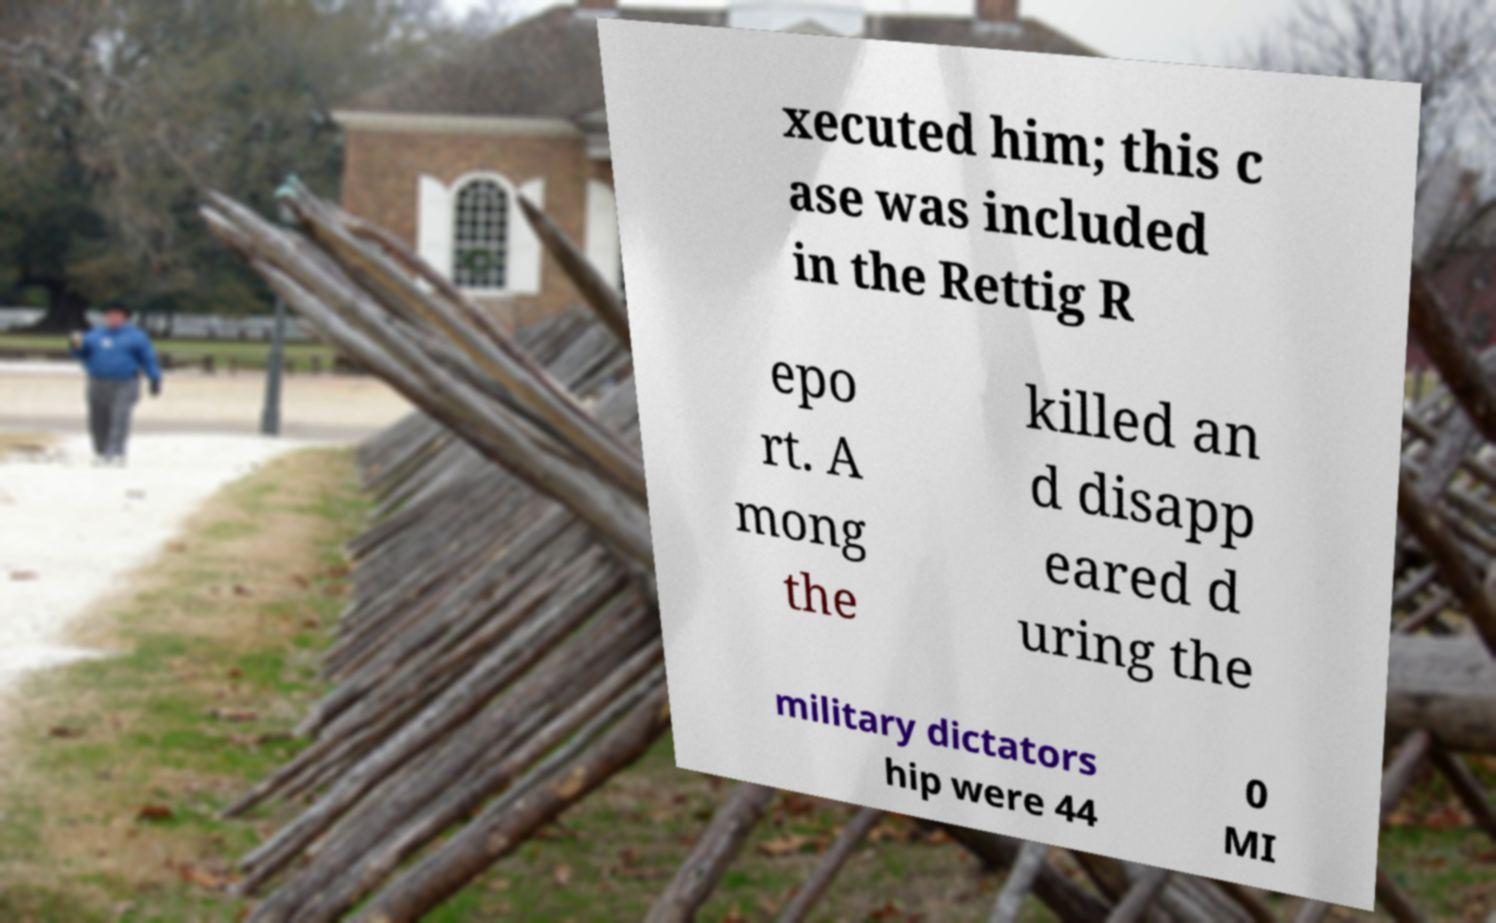Could you assist in decoding the text presented in this image and type it out clearly? xecuted him; this c ase was included in the Rettig R epo rt. A mong the killed an d disapp eared d uring the military dictators hip were 44 0 MI 